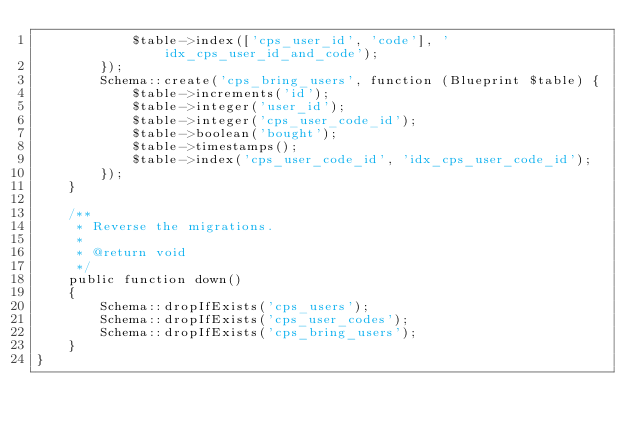Convert code to text. <code><loc_0><loc_0><loc_500><loc_500><_PHP_>            $table->index(['cps_user_id', 'code'], 'idx_cps_user_id_and_code');
        });
        Schema::create('cps_bring_users', function (Blueprint $table) { 
            $table->increments('id');
            $table->integer('user_id');
            $table->integer('cps_user_code_id');
            $table->boolean('bought');
            $table->timestamps();
            $table->index('cps_user_code_id', 'idx_cps_user_code_id');
        });
    }

    /**
     * Reverse the migrations.
     *
     * @return void
     */
    public function down()
    {
        Schema::dropIfExists('cps_users');
        Schema::dropIfExists('cps_user_codes');
        Schema::dropIfExists('cps_bring_users');
    }
}
</code> 